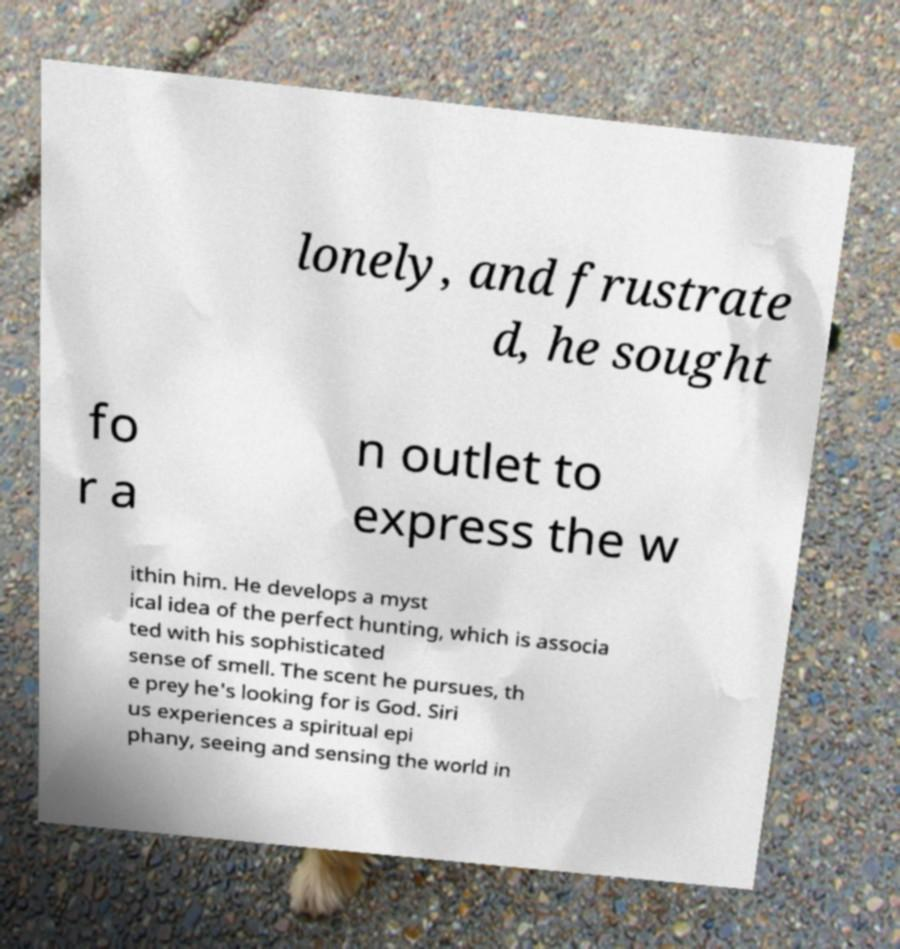Please read and relay the text visible in this image. What does it say? lonely, and frustrate d, he sought fo r a n outlet to express the w ithin him. He develops a myst ical idea of the perfect hunting, which is associa ted with his sophisticated sense of smell. The scent he pursues, th e prey he's looking for is God. Siri us experiences a spiritual epi phany, seeing and sensing the world in 